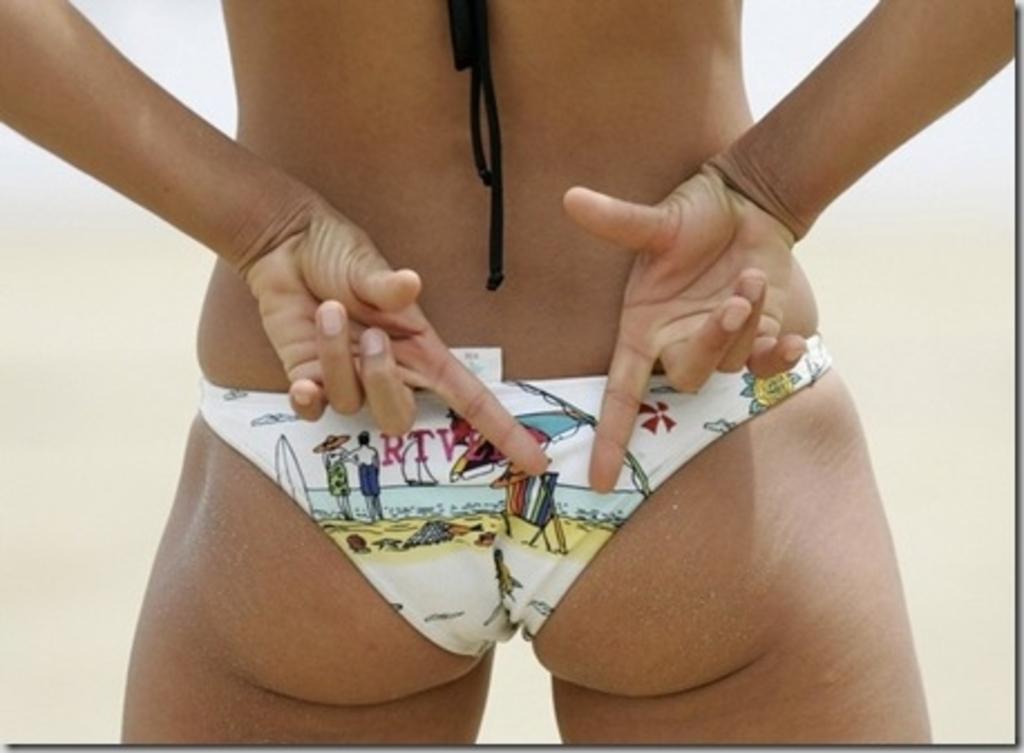Can you describe this image briefly? In this picture we can see a person wearing an undergarment, we can see the fingers of a person showing some sign. 